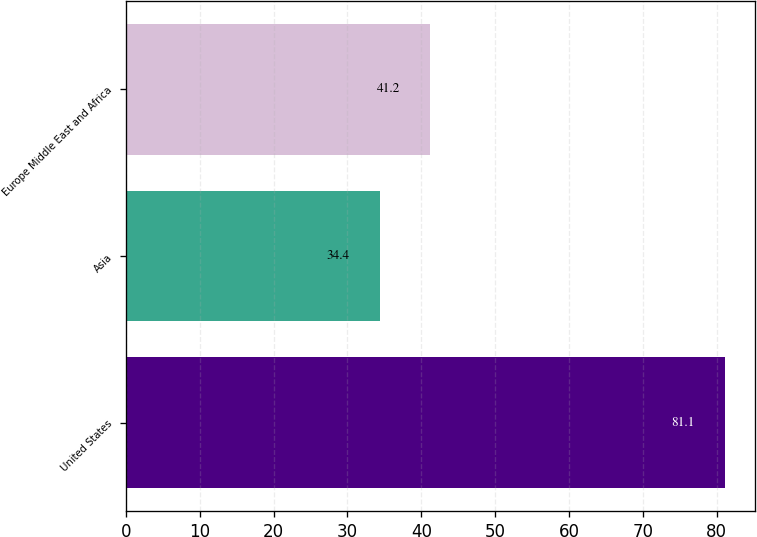Convert chart to OTSL. <chart><loc_0><loc_0><loc_500><loc_500><bar_chart><fcel>United States<fcel>Asia<fcel>Europe Middle East and Africa<nl><fcel>81.1<fcel>34.4<fcel>41.2<nl></chart> 